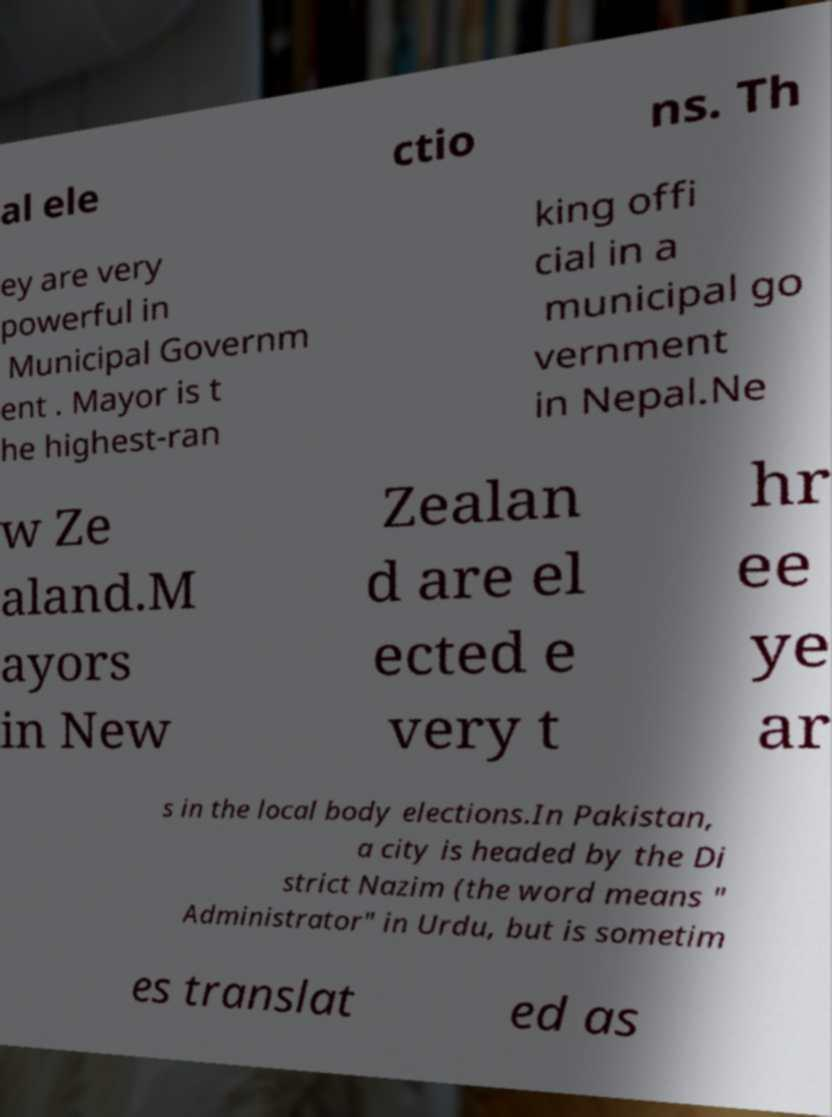What messages or text are displayed in this image? I need them in a readable, typed format. al ele ctio ns. Th ey are very powerful in Municipal Governm ent . Mayor is t he highest-ran king offi cial in a municipal go vernment in Nepal.Ne w Ze aland.M ayors in New Zealan d are el ected e very t hr ee ye ar s in the local body elections.In Pakistan, a city is headed by the Di strict Nazim (the word means " Administrator" in Urdu, but is sometim es translat ed as 